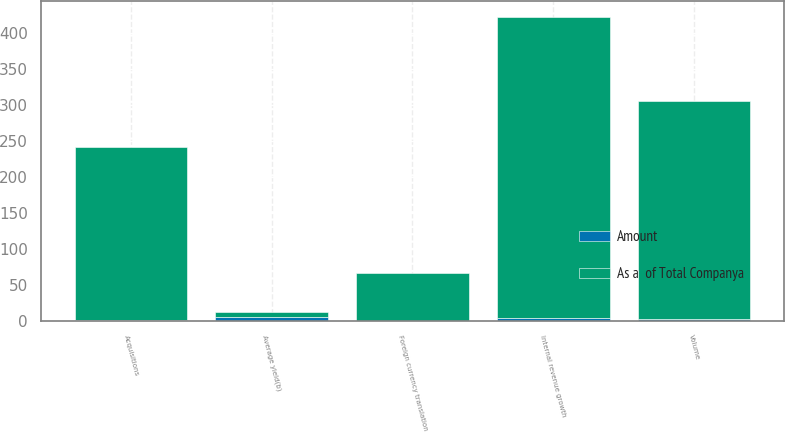<chart> <loc_0><loc_0><loc_500><loc_500><stacked_bar_chart><ecel><fcel>Average yield(b)<fcel>Volume<fcel>Internal revenue growth<fcel>Acquisitions<fcel>Foreign currency translation<nl><fcel>As a  of Total Companya<fcel>6.1<fcel>304<fcel>420<fcel>240<fcel>66<nl><fcel>Amount<fcel>6.1<fcel>2.6<fcel>3.5<fcel>2<fcel>0.6<nl></chart> 